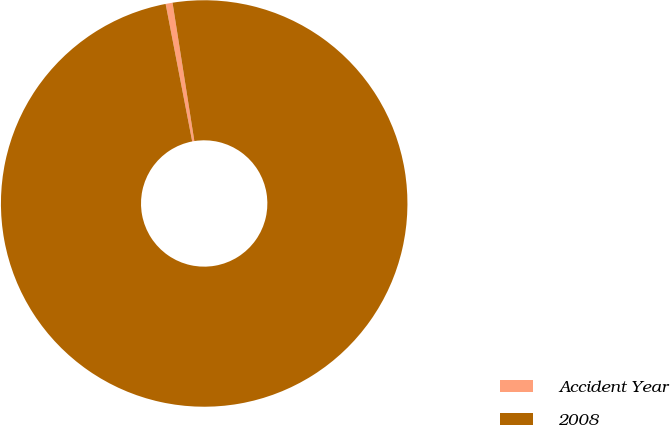Convert chart. <chart><loc_0><loc_0><loc_500><loc_500><pie_chart><fcel>Accident Year<fcel>2008<nl><fcel>0.55%<fcel>99.45%<nl></chart> 